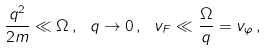Convert formula to latex. <formula><loc_0><loc_0><loc_500><loc_500>\frac { q ^ { 2 } } { 2 m } \ll \Omega \, , \ q \rightarrow 0 \, , \ v _ { F } \ll \frac { \Omega } { q } = v _ { \varphi } \, ,</formula> 